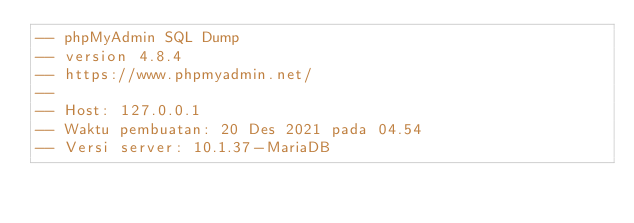Convert code to text. <code><loc_0><loc_0><loc_500><loc_500><_SQL_>-- phpMyAdmin SQL Dump
-- version 4.8.4
-- https://www.phpmyadmin.net/
--
-- Host: 127.0.0.1
-- Waktu pembuatan: 20 Des 2021 pada 04.54
-- Versi server: 10.1.37-MariaDB</code> 